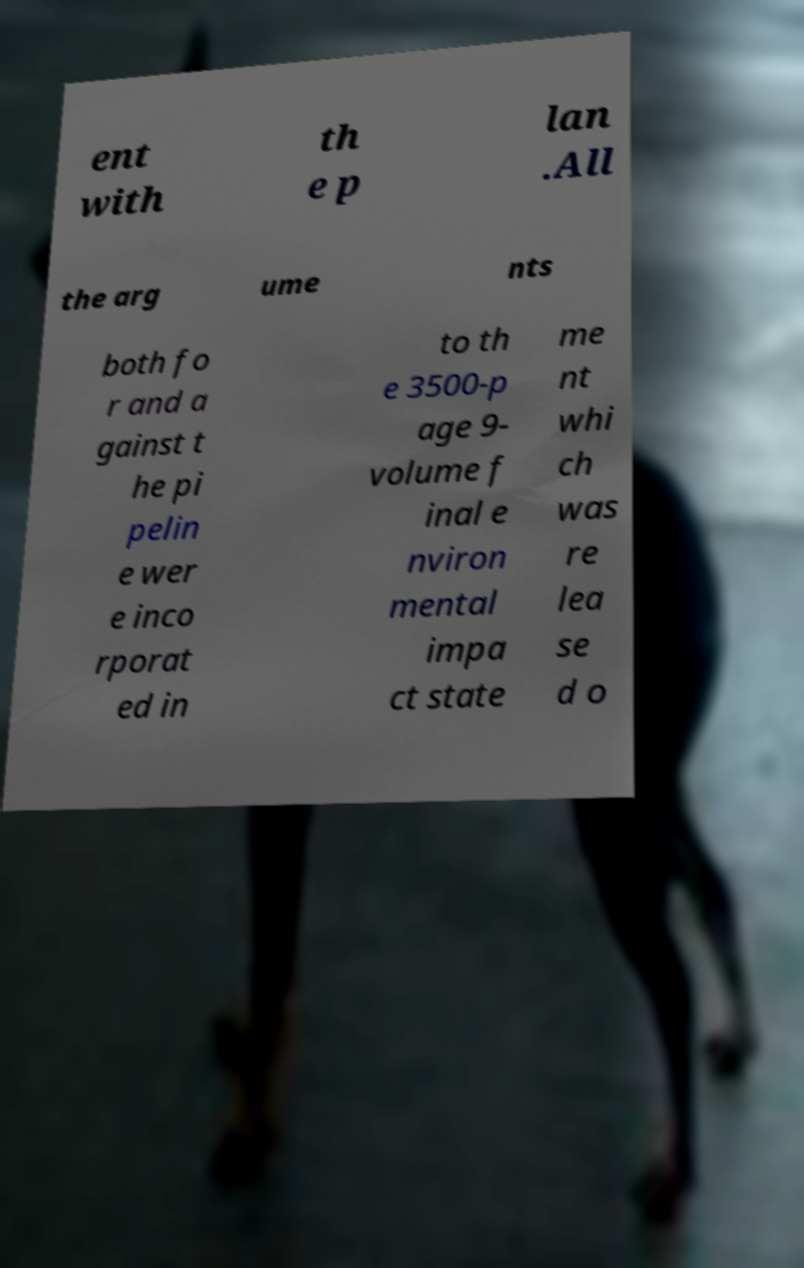For documentation purposes, I need the text within this image transcribed. Could you provide that? ent with th e p lan .All the arg ume nts both fo r and a gainst t he pi pelin e wer e inco rporat ed in to th e 3500-p age 9- volume f inal e nviron mental impa ct state me nt whi ch was re lea se d o 